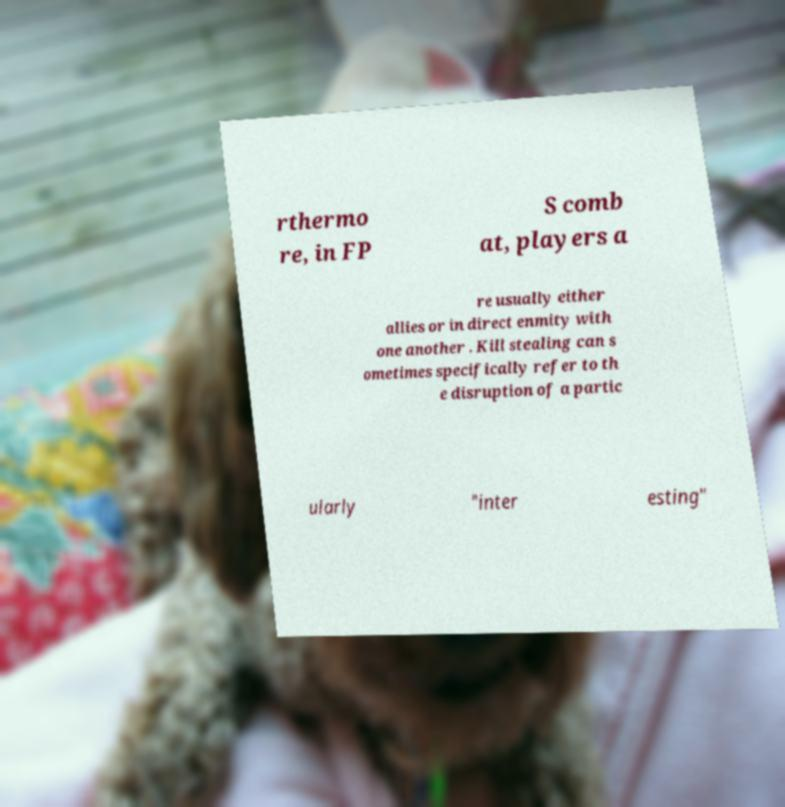What messages or text are displayed in this image? I need them in a readable, typed format. rthermo re, in FP S comb at, players a re usually either allies or in direct enmity with one another . Kill stealing can s ometimes specifically refer to th e disruption of a partic ularly "inter esting" 